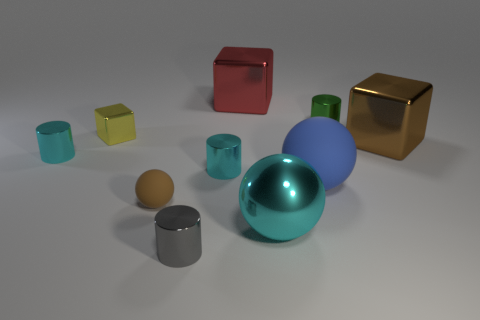Subtract all blocks. How many objects are left? 7 Subtract 0 blue cubes. How many objects are left? 10 Subtract all yellow cubes. Subtract all big blocks. How many objects are left? 7 Add 5 large red objects. How many large red objects are left? 6 Add 1 big metal blocks. How many big metal blocks exist? 3 